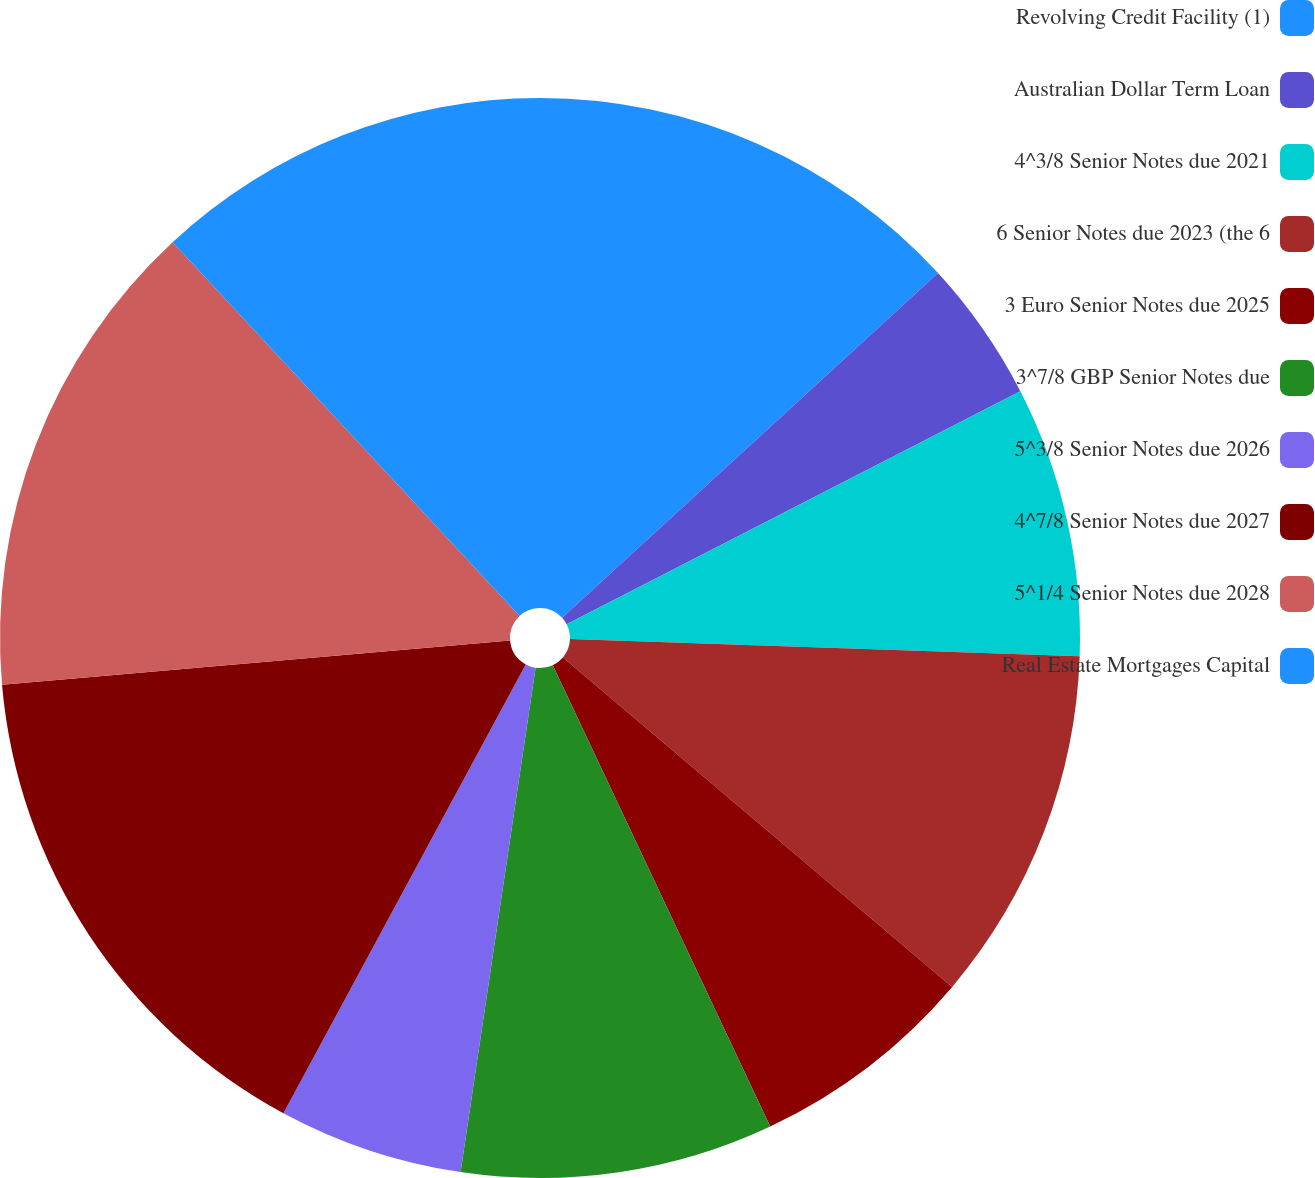Convert chart to OTSL. <chart><loc_0><loc_0><loc_500><loc_500><pie_chart><fcel>Revolving Credit Facility (1)<fcel>Australian Dollar Term Loan<fcel>4^3/8 Senior Notes due 2021<fcel>6 Senior Notes due 2023 (the 6<fcel>3 Euro Senior Notes due 2025<fcel>3^7/8 GBP Senior Notes due<fcel>5^3/8 Senior Notes due 2026<fcel>4^7/8 Senior Notes due 2027<fcel>5^1/4 Senior Notes due 2028<fcel>Real Estate Mortgages Capital<nl><fcel>13.19%<fcel>4.26%<fcel>8.09%<fcel>10.64%<fcel>6.81%<fcel>9.36%<fcel>5.53%<fcel>15.74%<fcel>14.47%<fcel>11.91%<nl></chart> 